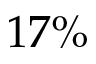Convert formula to latex. <formula><loc_0><loc_0><loc_500><loc_500>1 7 \%</formula> 